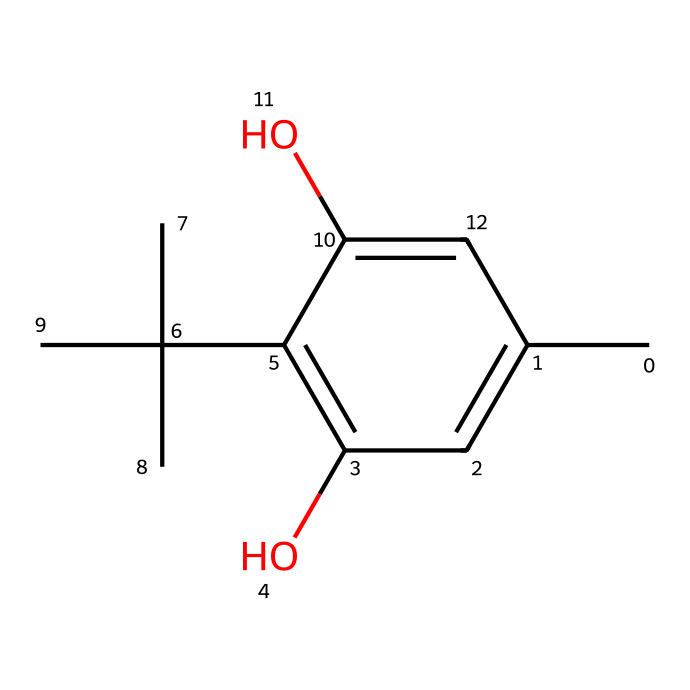What is the molecular formula of the compound? To deduce the molecular formula, we count the number of each type of atom present in the SMILES representation. The structure indicates the presence of 15 carbon atoms, 22 hydrogen atoms, and 4 oxygen atoms. Therefore, the molecular formula is C15H22O4.
Answer: C15H22O4 How many hydroxyl (OH) groups are present? The chemical structure includes two distinct hydroxyl (OH) groups, which can be identified by looking for the -OH functionalities directly attached to the aromatic ring.
Answer: 2 What type of chemical structure is indicated by the presence of a benzene ring? The presence of a benzene ring characterizes this compound as an aromatic compound, which is a defining feature of phenolic compounds due to their cyclic structure and resonance stability.
Answer: aromatic What is the primary functional group present in this molecule? The primary functional group is the hydroxyl group (-OH), identified by its direct attachment to the aromatic benzene structure, which is characteristic of phenols.
Answer: hydroxyl How many carbon atoms are connected to the central benzene ring? Counting the carbon atoms that are directly connected to the benzene ring in the SMILES structure, we find there are 3 carbon atoms attached to it outside of the ring through additional branches (one of which is a tertiary carbon), resulting in a total of 3 branched carbons bonded to the ring.
Answer: 3 What type of antioxidant property is likely provided by this compound? Given its phenolic structure and presence of hydroxyl groups, this compound likely exhibits properties associated with phenolic antioxidants, known for their ability to neutralize free radicals and prevent oxidative damage.
Answer: antioxidant 